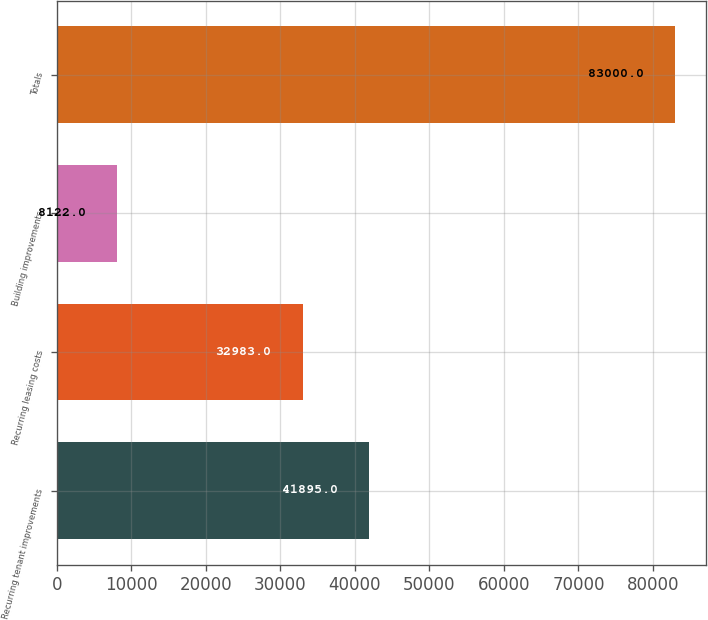Convert chart. <chart><loc_0><loc_0><loc_500><loc_500><bar_chart><fcel>Recurring tenant improvements<fcel>Recurring leasing costs<fcel>Building improvements<fcel>Totals<nl><fcel>41895<fcel>32983<fcel>8122<fcel>83000<nl></chart> 